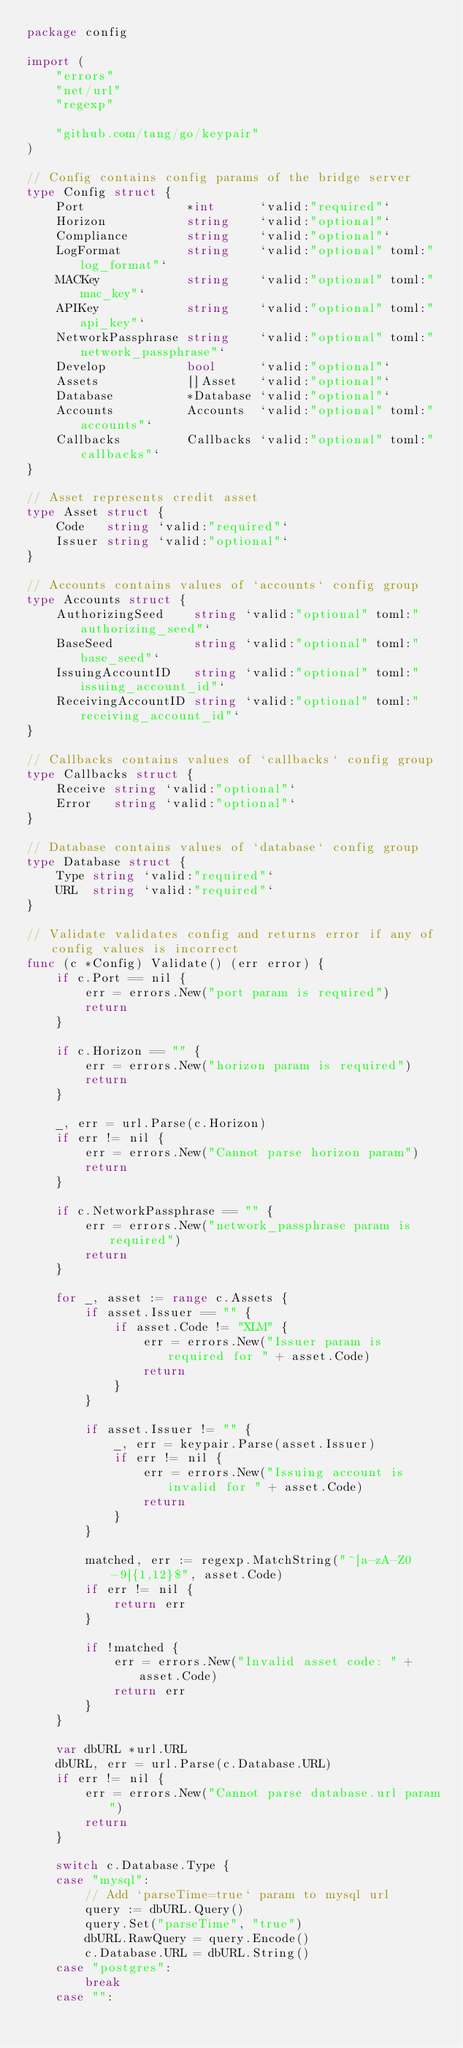Convert code to text. <code><loc_0><loc_0><loc_500><loc_500><_Go_>package config

import (
	"errors"
	"net/url"
	"regexp"

	"github.com/tang/go/keypair"
)

// Config contains config params of the bridge server
type Config struct {
	Port              *int      `valid:"required"`
	Horizon           string    `valid:"optional"`
	Compliance        string    `valid:"optional"`
	LogFormat         string    `valid:"optional" toml:"log_format"`
	MACKey            string    `valid:"optional" toml:"mac_key"`
	APIKey            string    `valid:"optional" toml:"api_key"`
	NetworkPassphrase string    `valid:"optional" toml:"network_passphrase"`
	Develop           bool      `valid:"optional"`
	Assets            []Asset   `valid:"optional"`
	Database          *Database `valid:"optional"`
	Accounts          Accounts  `valid:"optional" toml:"accounts"`
	Callbacks         Callbacks `valid:"optional" toml:"callbacks"`
}

// Asset represents credit asset
type Asset struct {
	Code   string `valid:"required"`
	Issuer string `valid:"optional"`
}

// Accounts contains values of `accounts` config group
type Accounts struct {
	AuthorizingSeed    string `valid:"optional" toml:"authorizing_seed"`
	BaseSeed           string `valid:"optional" toml:"base_seed"`
	IssuingAccountID   string `valid:"optional" toml:"issuing_account_id"`
	ReceivingAccountID string `valid:"optional" toml:"receiving_account_id"`
}

// Callbacks contains values of `callbacks` config group
type Callbacks struct {
	Receive string `valid:"optional"`
	Error   string `valid:"optional"`
}

// Database contains values of `database` config group
type Database struct {
	Type string `valid:"required"`
	URL  string `valid:"required"`
}

// Validate validates config and returns error if any of config values is incorrect
func (c *Config) Validate() (err error) {
	if c.Port == nil {
		err = errors.New("port param is required")
		return
	}

	if c.Horizon == "" {
		err = errors.New("horizon param is required")
		return
	}

	_, err = url.Parse(c.Horizon)
	if err != nil {
		err = errors.New("Cannot parse horizon param")
		return
	}

	if c.NetworkPassphrase == "" {
		err = errors.New("network_passphrase param is required")
		return
	}

	for _, asset := range c.Assets {
		if asset.Issuer == "" {
			if asset.Code != "XLM" {
				err = errors.New("Issuer param is required for " + asset.Code)
				return
			}
		}

		if asset.Issuer != "" {
			_, err = keypair.Parse(asset.Issuer)
			if err != nil {
				err = errors.New("Issuing account is invalid for " + asset.Code)
				return
			}
		}

		matched, err := regexp.MatchString("^[a-zA-Z0-9]{1,12}$", asset.Code)
		if err != nil {
			return err
		}

		if !matched {
			err = errors.New("Invalid asset code: " + asset.Code)
			return err
		}
	}

	var dbURL *url.URL
	dbURL, err = url.Parse(c.Database.URL)
	if err != nil {
		err = errors.New("Cannot parse database.url param")
		return
	}

	switch c.Database.Type {
	case "mysql":
		// Add `parseTime=true` param to mysql url
		query := dbURL.Query()
		query.Set("parseTime", "true")
		dbURL.RawQuery = query.Encode()
		c.Database.URL = dbURL.String()
	case "postgres":
		break
	case "":</code> 